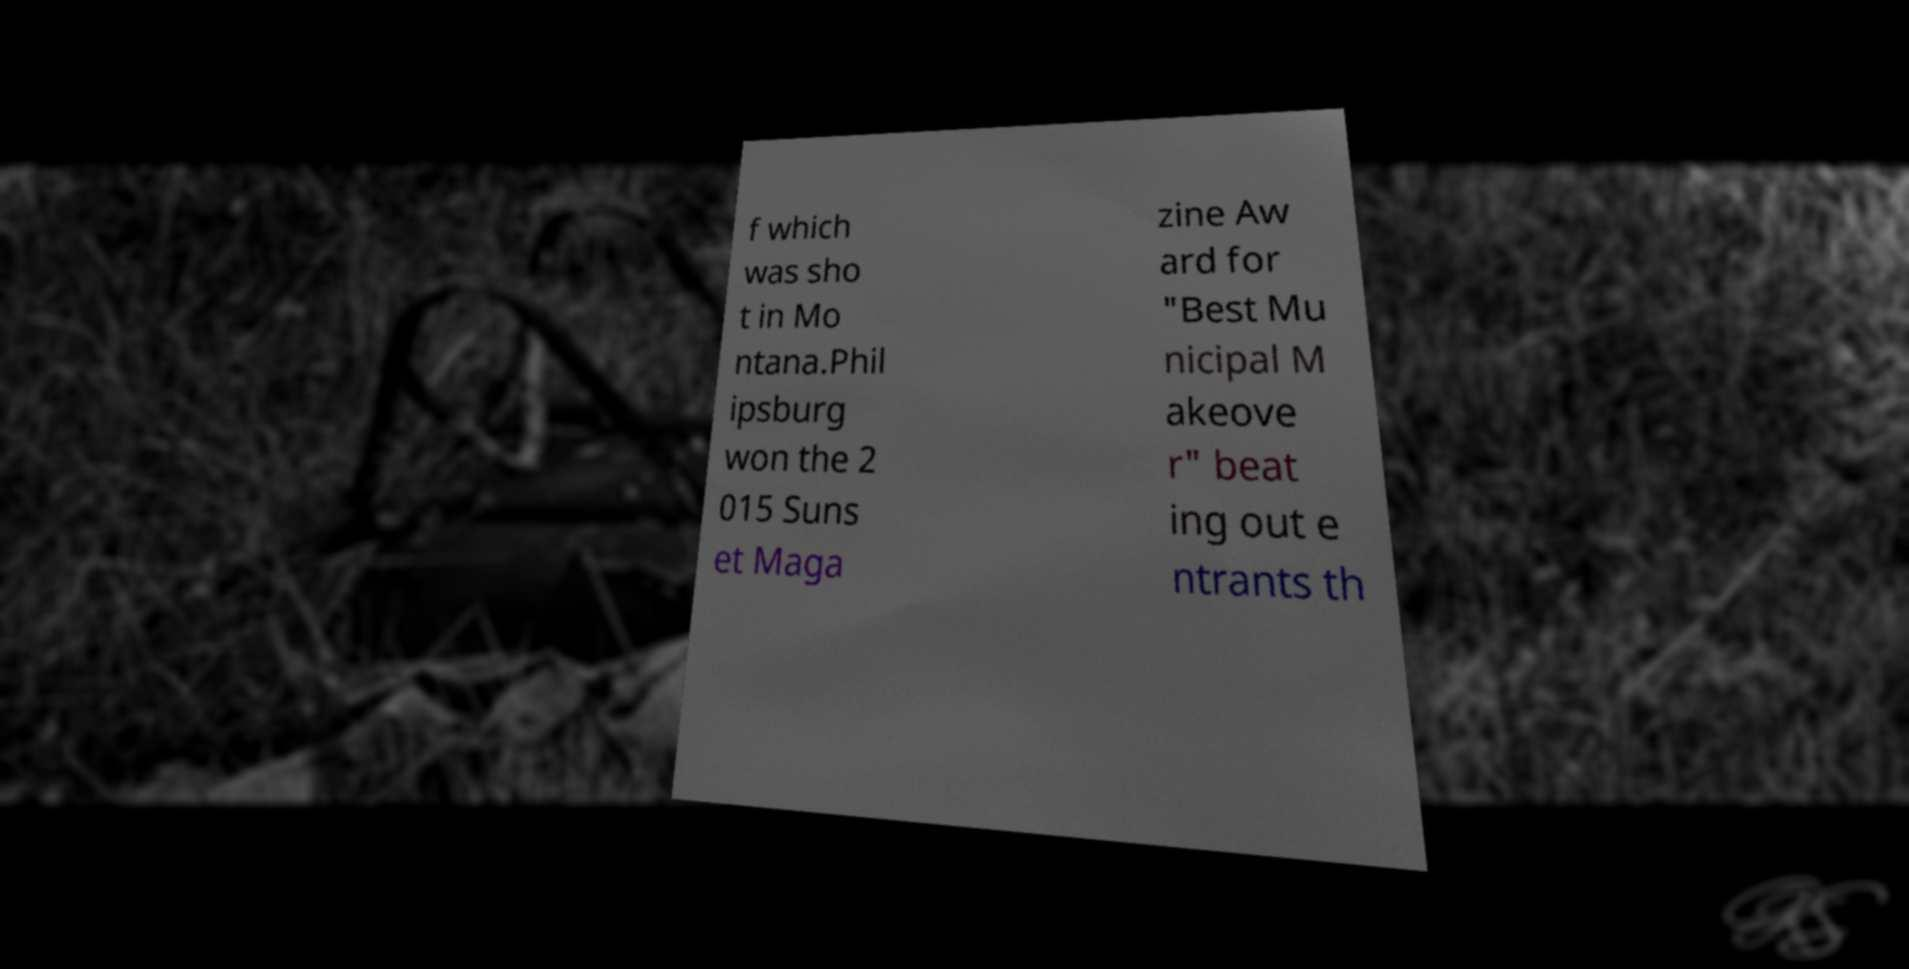There's text embedded in this image that I need extracted. Can you transcribe it verbatim? f which was sho t in Mo ntana.Phil ipsburg won the 2 015 Suns et Maga zine Aw ard for "Best Mu nicipal M akeove r" beat ing out e ntrants th 